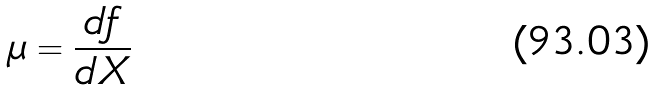Convert formula to latex. <formula><loc_0><loc_0><loc_500><loc_500>\mu = \frac { d f } { d X }</formula> 